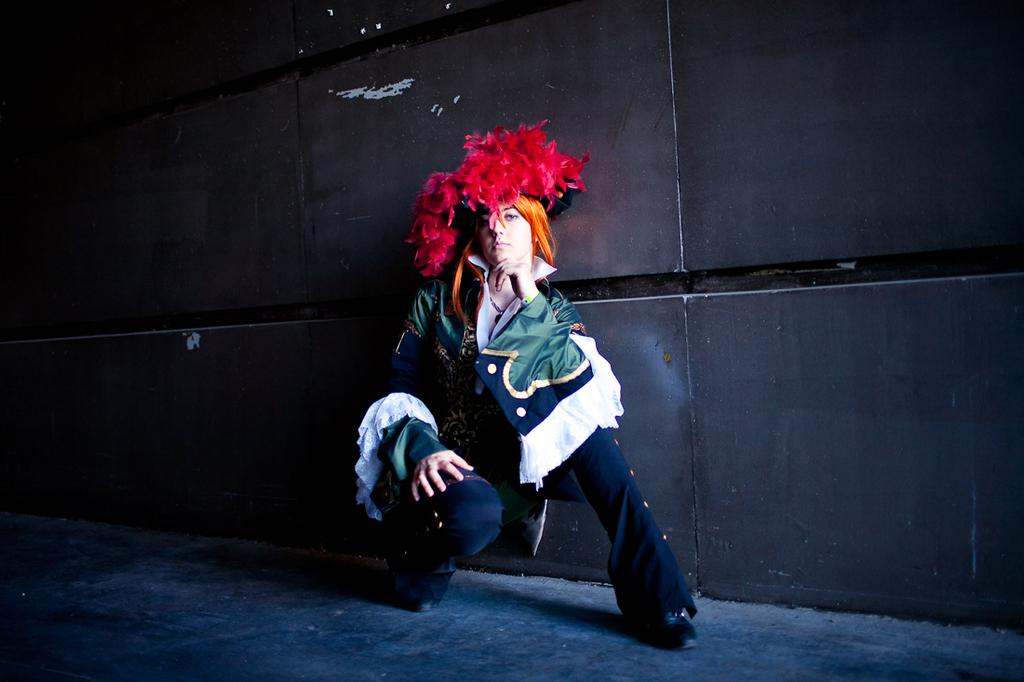Who is present in the image? There is a woman in the image. What is the woman doing in the image? The woman is sitting on the ground. What can be seen in the background of the image? There is a wall in the background of the image. What type of stone is the woman using to change the organization of the image? There is no stone or indication of changing the organization of the image; the woman is simply sitting on the ground. 